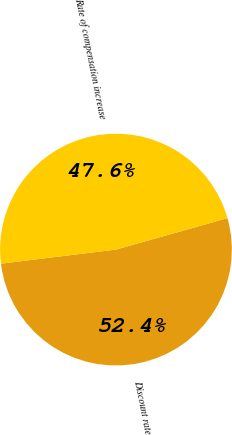Convert chart. <chart><loc_0><loc_0><loc_500><loc_500><pie_chart><fcel>Discount rate<fcel>Rate of compensation increase<nl><fcel>52.43%<fcel>47.57%<nl></chart> 